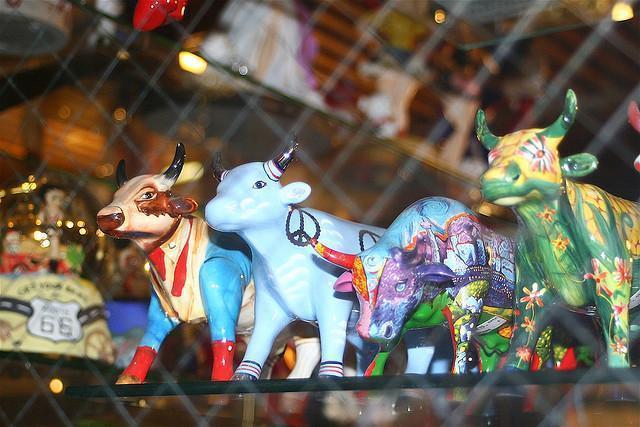How many cows can be seen?
Give a very brief answer. 3. How many men are in the picture?
Give a very brief answer. 0. 